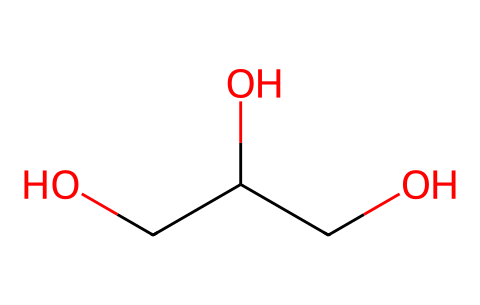What is the name of this chemical? The SMILES representation indicates that the chemical consists of three carbon atoms, making it propan-1,2,3-triol, commonly known as glycerol.
Answer: glycerol How many hydroxyl groups are present in this molecule? In the structure, there are three -OH (hydroxyl) groups attached to the carbon backbone. This is seen from the 'O' in the SMILES after each carbon.
Answer: three What is the total number of hydrogen atoms in glycerol? Each carbon atom typically bonds with enough hydrogen atoms to satisfy the tetravalence of carbon. After considering the presence of three hydroxyl groups, the total number of hydrogen atoms is eight.
Answer: eight What type of compound is glycerol? Given the structure with multiple hydroxyl (-OH) groups, glycerol is categorized as a polyol or sugar alcohol, indicating its classification as an organic alcohol.
Answer: polyol Does glycerol contain any double bonds? The SMILES representation shows only single bonds between carbon and oxygen, confirming that there are no double bonds present in its structure.
Answer: no How does the arrangement of glycerol affect its solubility in water? The presence of three hydroxyl groups raises polarity in glycerol, enhancing its ability to form hydrogen bonds with water, thus increasing solubility.
Answer: increases solubility Is glycerol considered a sweet-tasting compound? Yes, glycerol has a naturally sweet taste, which can be attributed to its structure, particularly due to the hydroxyl groups contributing to sweetness perception.
Answer: yes 